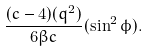<formula> <loc_0><loc_0><loc_500><loc_500>\frac { ( c - 4 ) ( q ^ { 2 } ) } { 6 \beta c } ( \sin ^ { 2 } \phi ) .</formula> 